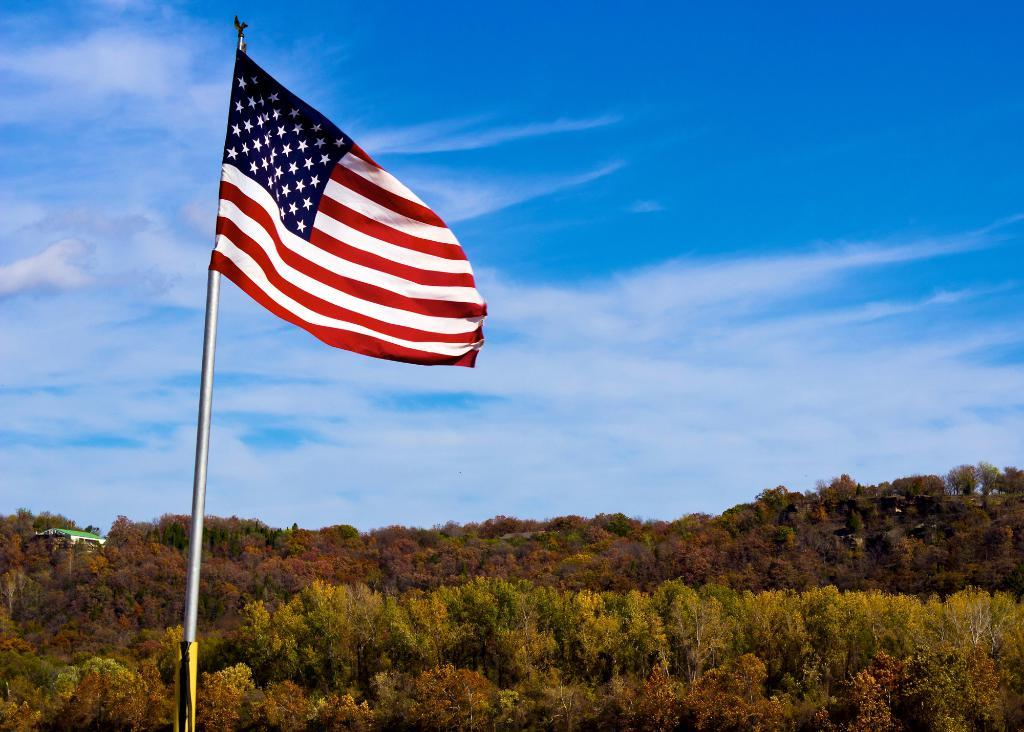What is the main subject of the image? The main subject of the image is an American flag. Where is the American flag located in the image? The American flag is on the left side of the image. What type of natural elements can be seen in the image? There are trees at the bottom side of the image. How many stems are visible on the American flag in the image? There are no stems present on the American flag in the image, as it is a flag and not a plant. Can you tell me how many times the American flag is folded in the image? The American flag is not folded in the image; it is unfurled and displayed. 